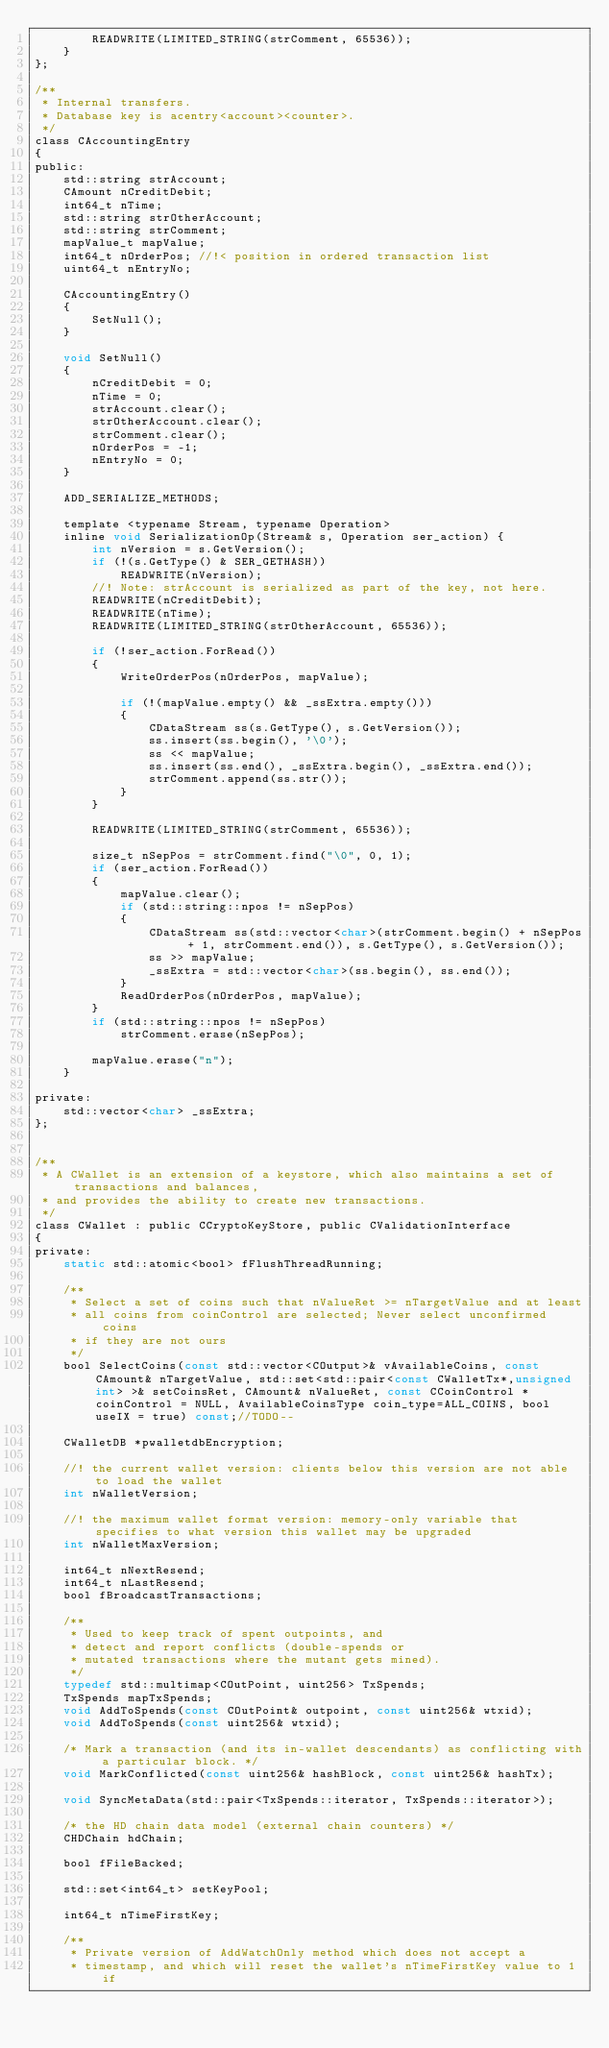<code> <loc_0><loc_0><loc_500><loc_500><_C_>        READWRITE(LIMITED_STRING(strComment, 65536));
    }
};

/**
 * Internal transfers.
 * Database key is acentry<account><counter>.
 */
class CAccountingEntry
{
public:
    std::string strAccount;
    CAmount nCreditDebit;
    int64_t nTime;
    std::string strOtherAccount;
    std::string strComment;
    mapValue_t mapValue;
    int64_t nOrderPos; //!< position in ordered transaction list
    uint64_t nEntryNo;

    CAccountingEntry()
    {
        SetNull();
    }

    void SetNull()
    {
        nCreditDebit = 0;
        nTime = 0;
        strAccount.clear();
        strOtherAccount.clear();
        strComment.clear();
        nOrderPos = -1;
        nEntryNo = 0;
    }

    ADD_SERIALIZE_METHODS;

    template <typename Stream, typename Operation>
    inline void SerializationOp(Stream& s, Operation ser_action) {
        int nVersion = s.GetVersion();
        if (!(s.GetType() & SER_GETHASH))
            READWRITE(nVersion);
        //! Note: strAccount is serialized as part of the key, not here.
        READWRITE(nCreditDebit);
        READWRITE(nTime);
        READWRITE(LIMITED_STRING(strOtherAccount, 65536));

        if (!ser_action.ForRead())
        {
            WriteOrderPos(nOrderPos, mapValue);

            if (!(mapValue.empty() && _ssExtra.empty()))
            {
                CDataStream ss(s.GetType(), s.GetVersion());
                ss.insert(ss.begin(), '\0');
                ss << mapValue;
                ss.insert(ss.end(), _ssExtra.begin(), _ssExtra.end());
                strComment.append(ss.str());
            }
        }

        READWRITE(LIMITED_STRING(strComment, 65536));

        size_t nSepPos = strComment.find("\0", 0, 1);
        if (ser_action.ForRead())
        {
            mapValue.clear();
            if (std::string::npos != nSepPos)
            {
                CDataStream ss(std::vector<char>(strComment.begin() + nSepPos + 1, strComment.end()), s.GetType(), s.GetVersion());
                ss >> mapValue;
                _ssExtra = std::vector<char>(ss.begin(), ss.end());
            }
            ReadOrderPos(nOrderPos, mapValue);
        }
        if (std::string::npos != nSepPos)
            strComment.erase(nSepPos);

        mapValue.erase("n");
    }

private:
    std::vector<char> _ssExtra;
};


/** 
 * A CWallet is an extension of a keystore, which also maintains a set of transactions and balances,
 * and provides the ability to create new transactions.
 */
class CWallet : public CCryptoKeyStore, public CValidationInterface
{
private:
    static std::atomic<bool> fFlushThreadRunning;

    /**
     * Select a set of coins such that nValueRet >= nTargetValue and at least
     * all coins from coinControl are selected; Never select unconfirmed coins
     * if they are not ours
     */
    bool SelectCoins(const std::vector<COutput>& vAvailableCoins, const CAmount& nTargetValue, std::set<std::pair<const CWalletTx*,unsigned int> >& setCoinsRet, CAmount& nValueRet, const CCoinControl *coinControl = NULL, AvailableCoinsType coin_type=ALL_COINS, bool useIX = true) const;//TODO--

    CWalletDB *pwalletdbEncryption;

    //! the current wallet version: clients below this version are not able to load the wallet
    int nWalletVersion;

    //! the maximum wallet format version: memory-only variable that specifies to what version this wallet may be upgraded
    int nWalletMaxVersion;

    int64_t nNextResend;
    int64_t nLastResend;
    bool fBroadcastTransactions;

    /**
     * Used to keep track of spent outpoints, and
     * detect and report conflicts (double-spends or
     * mutated transactions where the mutant gets mined).
     */
    typedef std::multimap<COutPoint, uint256> TxSpends;
    TxSpends mapTxSpends;
    void AddToSpends(const COutPoint& outpoint, const uint256& wtxid);
    void AddToSpends(const uint256& wtxid);

    /* Mark a transaction (and its in-wallet descendants) as conflicting with a particular block. */
    void MarkConflicted(const uint256& hashBlock, const uint256& hashTx);

    void SyncMetaData(std::pair<TxSpends::iterator, TxSpends::iterator>);

    /* the HD chain data model (external chain counters) */
    CHDChain hdChain;

    bool fFileBacked;

    std::set<int64_t> setKeyPool;

    int64_t nTimeFirstKey;

    /**
     * Private version of AddWatchOnly method which does not accept a
     * timestamp, and which will reset the wallet's nTimeFirstKey value to 1 if</code> 